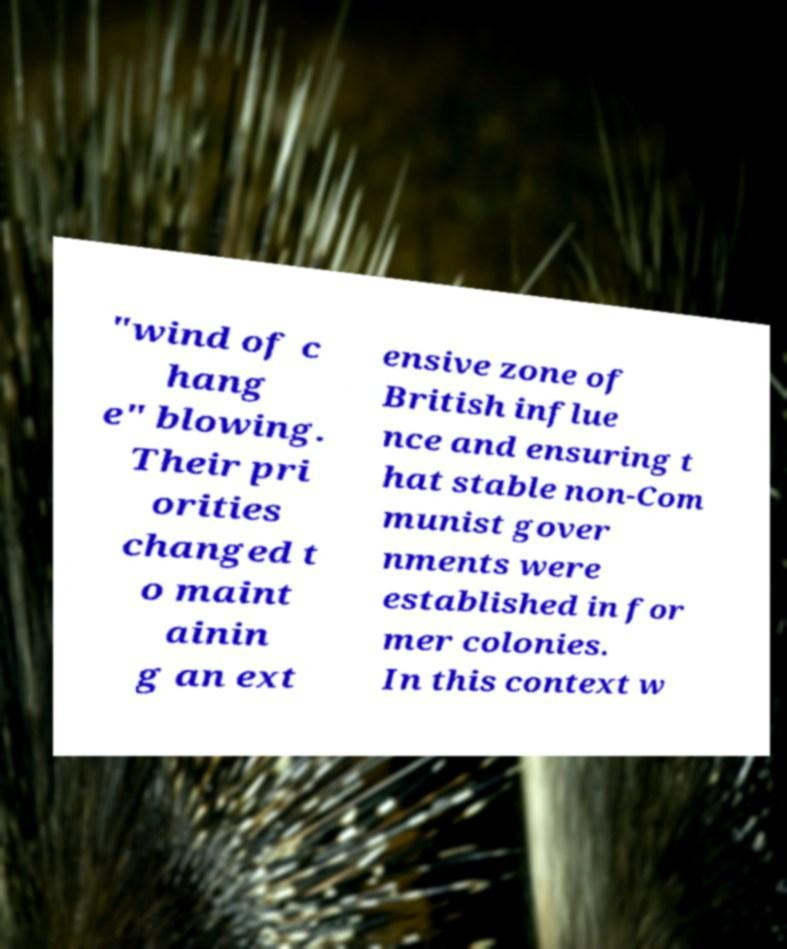Can you accurately transcribe the text from the provided image for me? "wind of c hang e" blowing. Their pri orities changed t o maint ainin g an ext ensive zone of British influe nce and ensuring t hat stable non-Com munist gover nments were established in for mer colonies. In this context w 